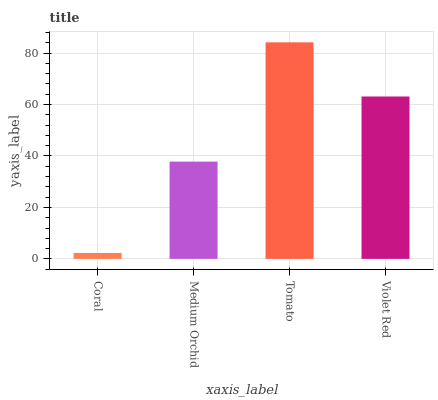Is Coral the minimum?
Answer yes or no. Yes. Is Tomato the maximum?
Answer yes or no. Yes. Is Medium Orchid the minimum?
Answer yes or no. No. Is Medium Orchid the maximum?
Answer yes or no. No. Is Medium Orchid greater than Coral?
Answer yes or no. Yes. Is Coral less than Medium Orchid?
Answer yes or no. Yes. Is Coral greater than Medium Orchid?
Answer yes or no. No. Is Medium Orchid less than Coral?
Answer yes or no. No. Is Violet Red the high median?
Answer yes or no. Yes. Is Medium Orchid the low median?
Answer yes or no. Yes. Is Medium Orchid the high median?
Answer yes or no. No. Is Tomato the low median?
Answer yes or no. No. 